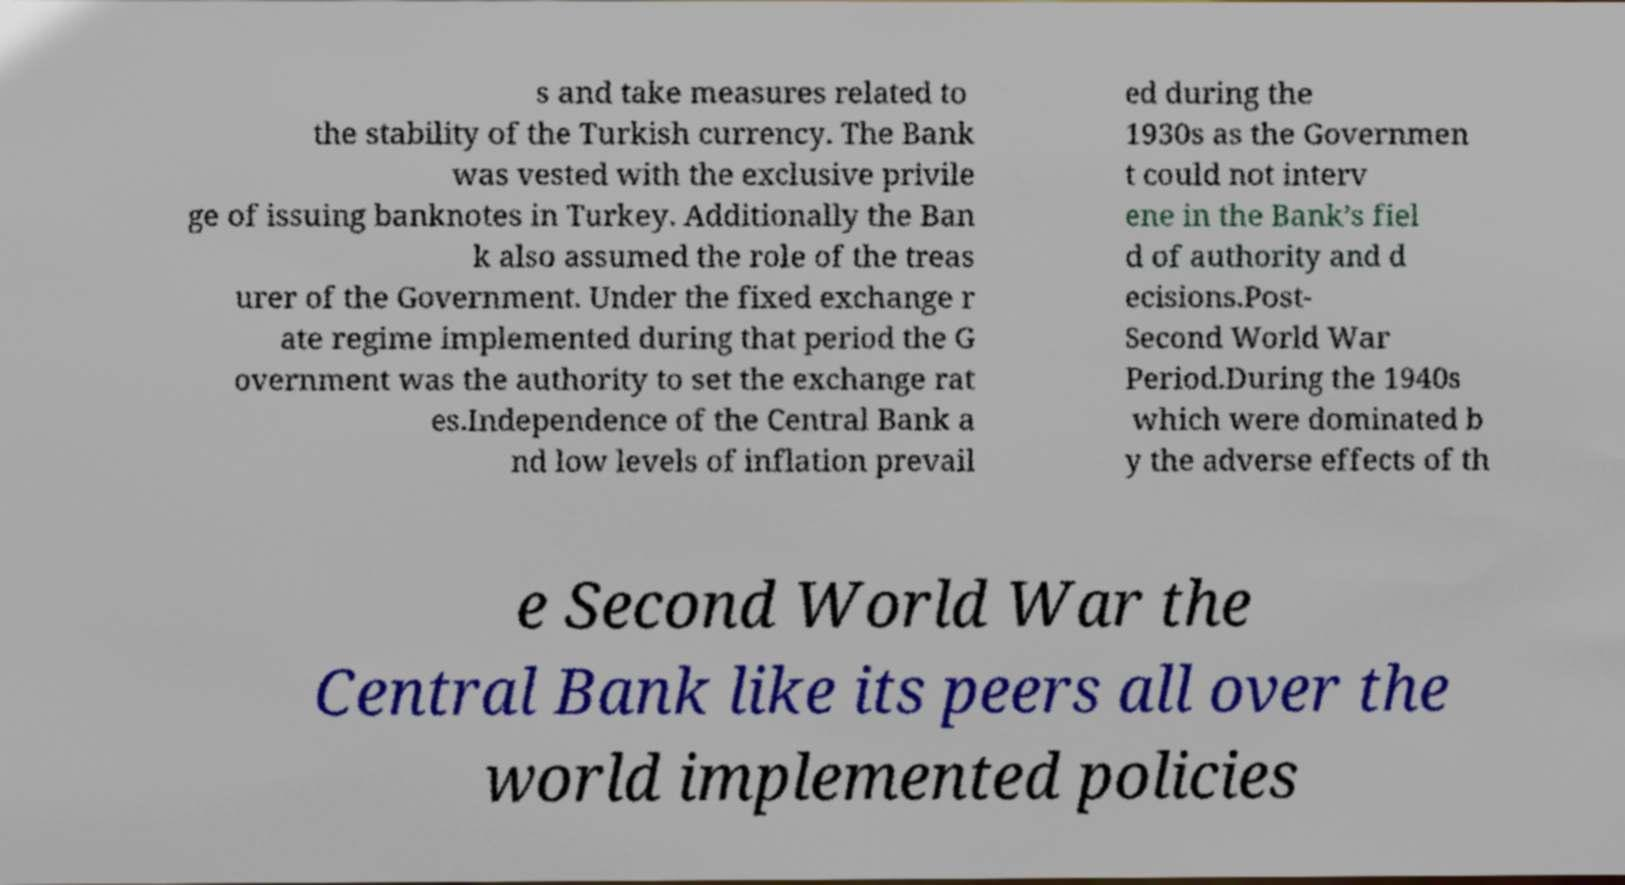Could you extract and type out the text from this image? s and take measures related to the stability of the Turkish currency. The Bank was vested with the exclusive privile ge of issuing banknotes in Turkey. Additionally the Ban k also assumed the role of the treas urer of the Government. Under the fixed exchange r ate regime implemented during that period the G overnment was the authority to set the exchange rat es.Independence of the Central Bank a nd low levels of inflation prevail ed during the 1930s as the Governmen t could not interv ene in the Bank’s fiel d of authority and d ecisions.Post- Second World War Period.During the 1940s which were dominated b y the adverse effects of th e Second World War the Central Bank like its peers all over the world implemented policies 